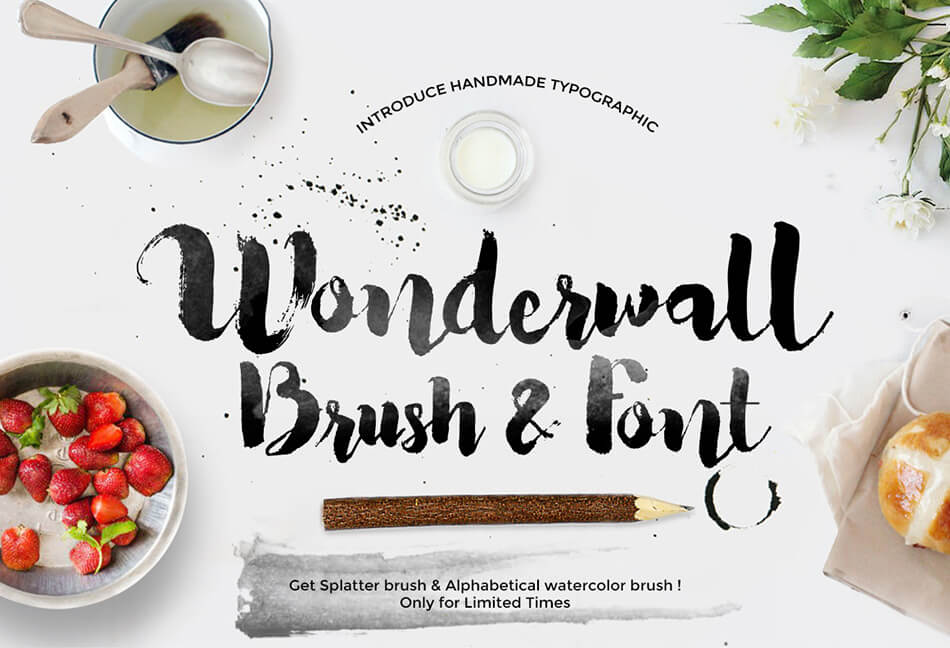Considering the elements presented in the advertisement, what might be the intended use or application for the 'Wonderwall' brush and font style, and how do these elements collectively enhance the appeal or functionality of the product being advertised? The 'Wonderwall' brush and font style is likely intended for use in graphic design, particularly for projects that require a handmade, artistic feel. The inclusion of art tools like the paintbrush and pencil, along with the use of a hand-painted type style for the word "Wonderwall", emphasize the creative and artistic potential of the product. The strawberries and bread could suggest that this font could be well-suited for designing materials in the food industry, such as menus or packaging. The greenery adds a natural, fresh element to the scene, which can be appealing to those looking for organic or natural-themed design elements. The splatter effect, alongside the text mentioning the availability of a splatter brush and watercolor brush, indicates that the product offers a variety of textures and effects, enhancing its appeal to potential customers seeking versatility in their design work. 